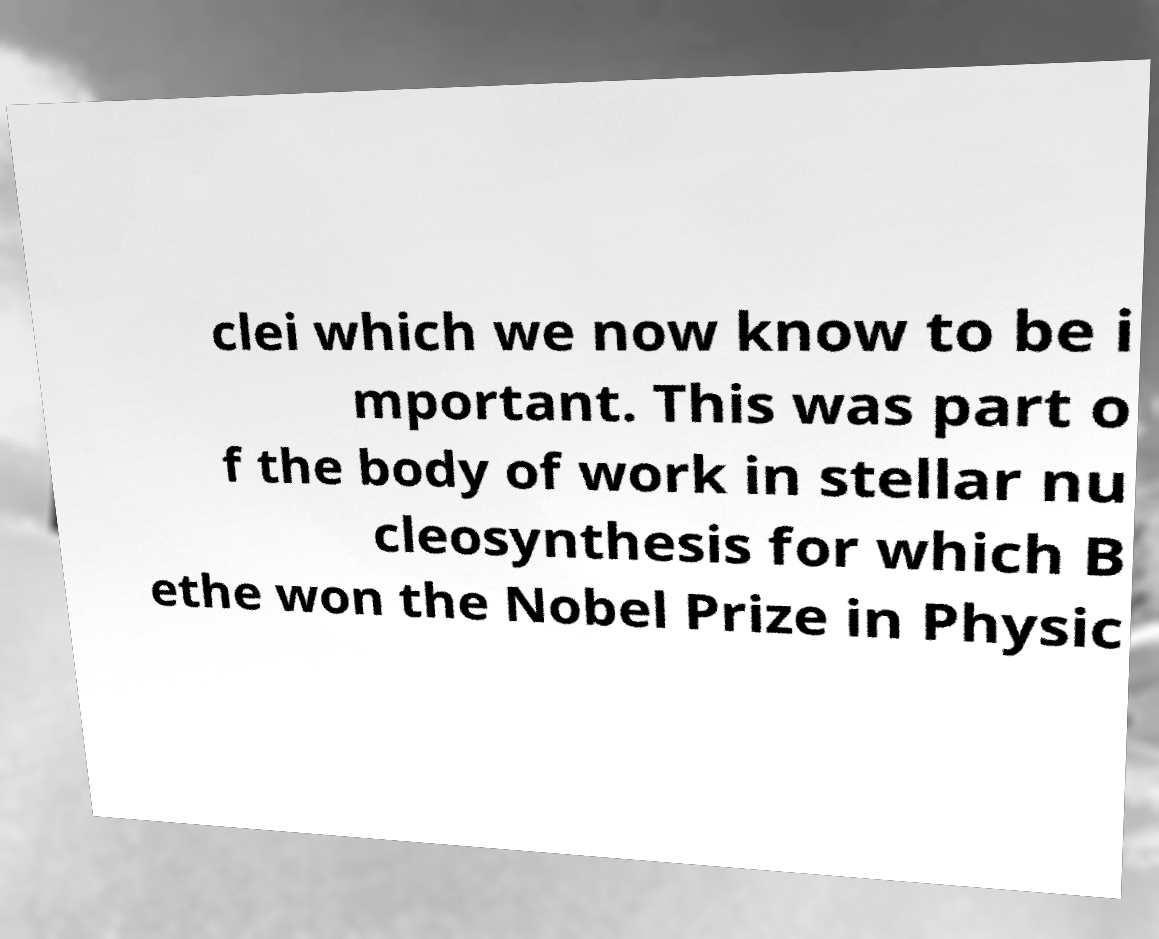Please identify and transcribe the text found in this image. clei which we now know to be i mportant. This was part o f the body of work in stellar nu cleosynthesis for which B ethe won the Nobel Prize in Physic 